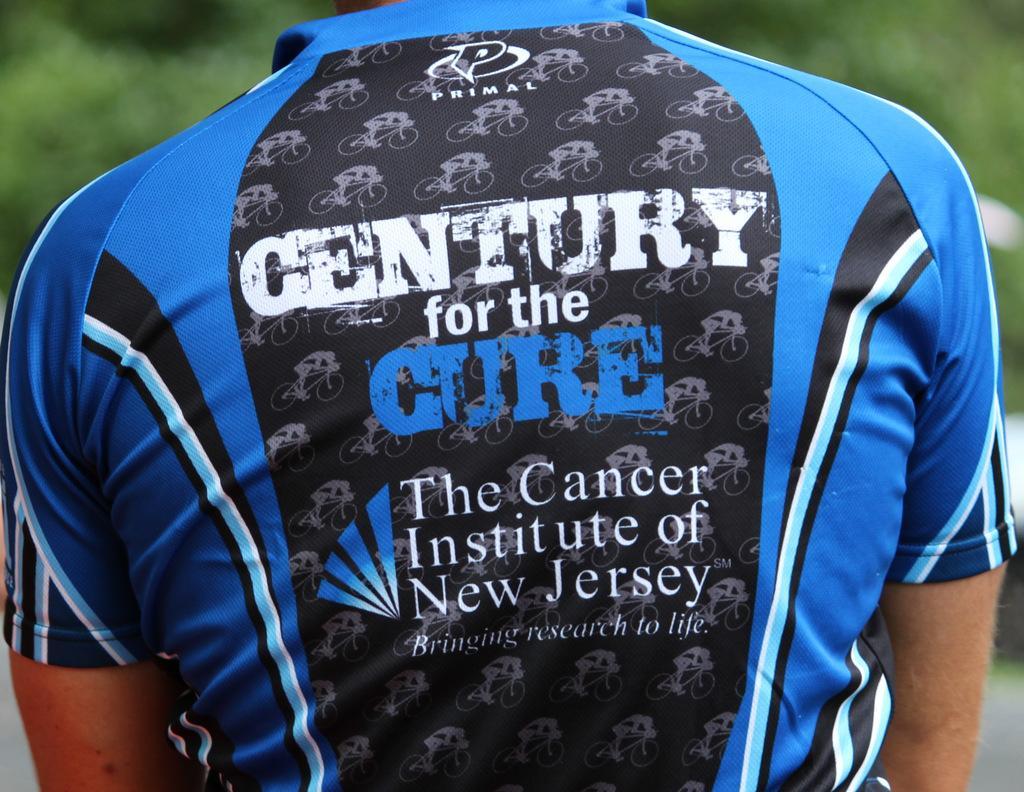Could you give a brief overview of what you see in this image? In this image I see a person who is wearing t-shirt which is of blue, black and white in color and I see something is written over here and I see that it is totally green in the background. 